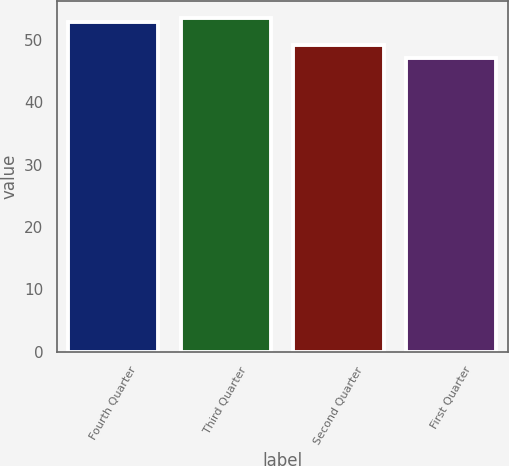<chart> <loc_0><loc_0><loc_500><loc_500><bar_chart><fcel>Fourth Quarter<fcel>Third Quarter<fcel>Second Quarter<fcel>First Quarter<nl><fcel>52.87<fcel>53.55<fcel>49.08<fcel>47.14<nl></chart> 